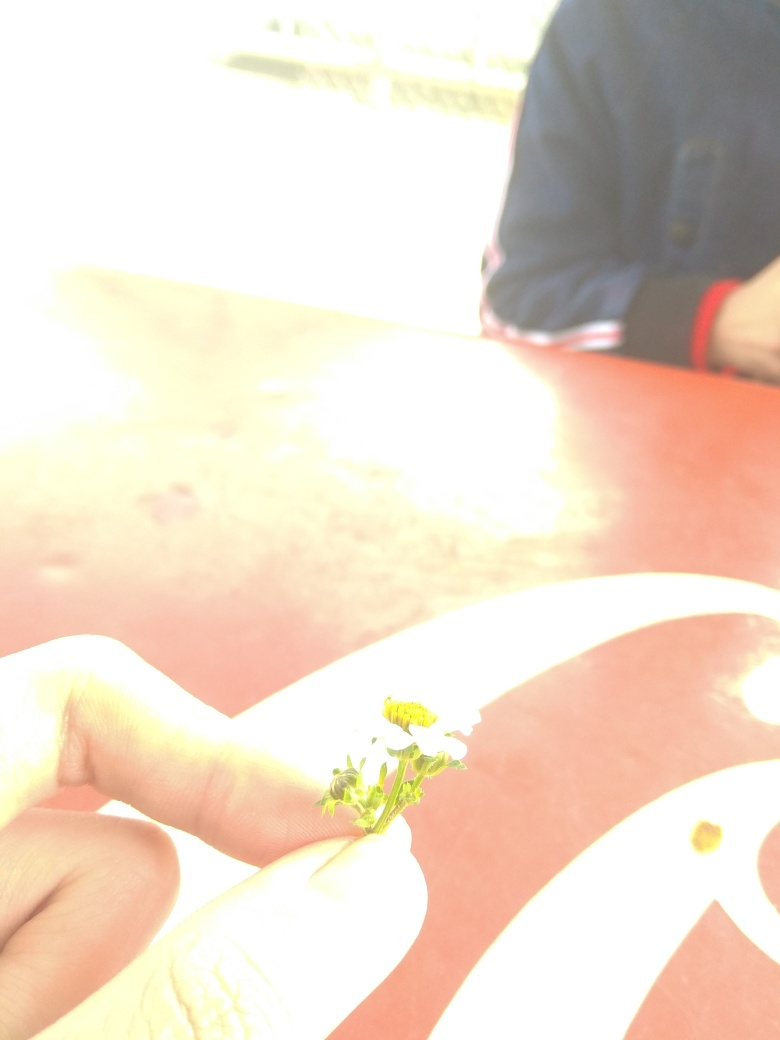What can you infer about the environment where this photo was taken? While specific details are obscured due to the overexposed background, the bright light suggests that the photo was taken outdoors in direct sunlight. The presence of a tabletop with a pattern indicates the setting might be a public space, such as a park or outdoor cafeteria. The relaxed posture of the hand holding the flower offers a sense of leisure or a brief pause to enjoy a simple natural element. 